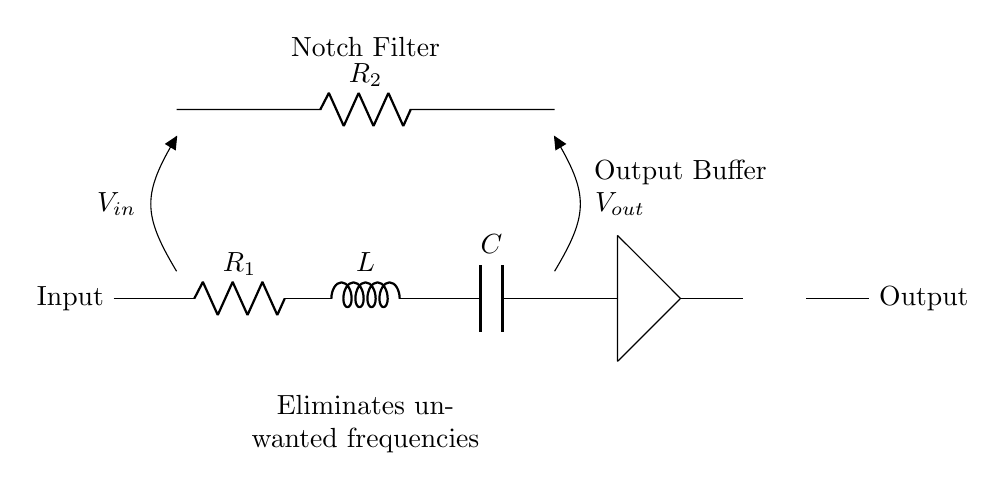What is the input of this circuit? The input of the circuit is labeled as "Input," which is located on the left side of the diagram, and indicated by a connection point leading into the circuit.
Answer: Input What components are in the series branch? The series branch consists of a resistor labeled R1, an inductor labeled L, and a capacitor labeled C, which are connected one after the other along the horizontal line in the circuit diagram.
Answer: R1, L, C What does the output buffer do? The output buffer is used to isolate the output voltage from the rest of the circuit, providing a stable output voltage and preventing loading effects. It can be identified by its position after the series RLC branch and showing connections to the output.
Answer: Isolates output What is the purpose of the notch filter? The purpose of the notch filter is to eliminate unwanted frequencies from the signal passing through it, which is noted in the circuit annotations as "Eliminates unwanted frequencies."
Answer: Eliminates unwanted frequencies How is the output voltage denoted? The output voltage is denoted by the label "Vout," indicated by an open loop connected at the output of the notch filter circuit where the signal is taken, typically identified after the output buffer.
Answer: Vout What value might R2 typically take? The specific value of R2 is not provided in the circuit diagram; however, in practical applications, it is generally chosen based on desired filter characteristics, which may range from a few hundred ohms to several kilo-ohms.
Answer: Depends on design Why is R2 connected in parallel with the capacitive and inductive network? R2 is connected in parallel to adjust the damping of the notch filter, which affects the filter's bandwidth and quality factor, thus providing control over the frequency response characteristics of the circuit.
Answer: Adjusts damping 